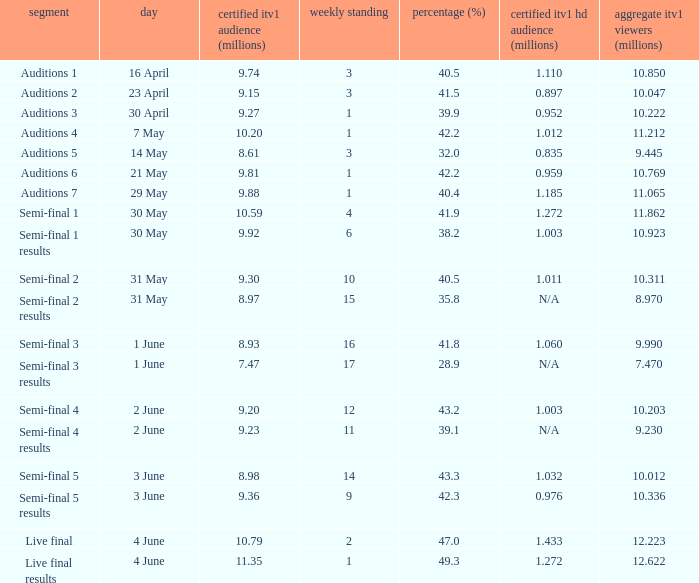What was the official ITV1 HD rating in millions for the episode that had an official ITV1 rating of 8.98 million? 1.032. 